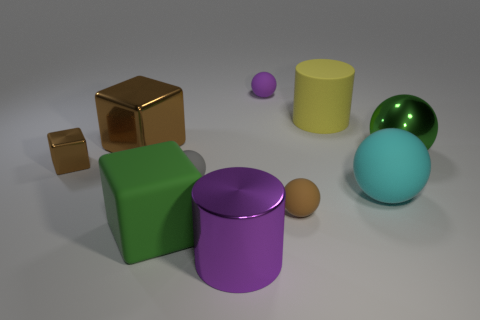Subtract 3 balls. How many balls are left? 2 Subtract all big cyan rubber spheres. How many spheres are left? 4 Subtract all green spheres. How many spheres are left? 4 Subtract all red spheres. Subtract all yellow cubes. How many spheres are left? 5 Subtract all blocks. How many objects are left? 7 Subtract 0 green cylinders. How many objects are left? 10 Subtract all tiny brown rubber balls. Subtract all small brown shiny objects. How many objects are left? 8 Add 3 purple metallic cylinders. How many purple metallic cylinders are left? 4 Add 1 tiny blue objects. How many tiny blue objects exist? 1 